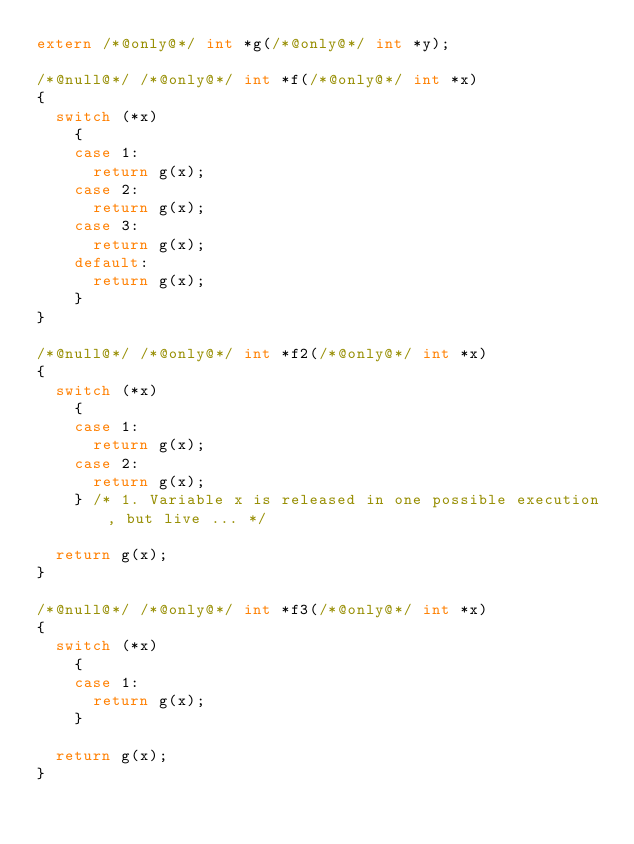Convert code to text. <code><loc_0><loc_0><loc_500><loc_500><_C_>extern /*@only@*/ int *g(/*@only@*/ int *y);

/*@null@*/ /*@only@*/ int *f(/*@only@*/ int *x)
{
  switch (*x)
    {
    case 1:
      return g(x);
    case 2:
      return g(x);
    case 3:
      return g(x);
    default:
      return g(x);
    }
}

/*@null@*/ /*@only@*/ int *f2(/*@only@*/ int *x)
{
  switch (*x)
    {
    case 1:
      return g(x);
    case 2:
      return g(x);
    } /* 1. Variable x is released in one possible execution, but live ... */

  return g(x);
}

/*@null@*/ /*@only@*/ int *f3(/*@only@*/ int *x)
{
  switch (*x)
    {
    case 1:
      return g(x);
    } 

  return g(x);
}
</code> 